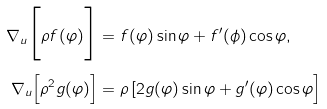<formula> <loc_0><loc_0><loc_500><loc_500>\nabla _ { u } \Big [ \rho f ( \varphi ) \Big ] & = f ( \varphi ) \sin \varphi + f ^ { \prime } ( \phi ) \cos \varphi , \\ \nabla _ { u } \Big [ \rho ^ { 2 } g ( \varphi ) \Big ] & = \rho \, [ 2 g ( \varphi ) \sin \varphi + g ^ { \prime } ( \varphi ) \cos \varphi \Big ]</formula> 